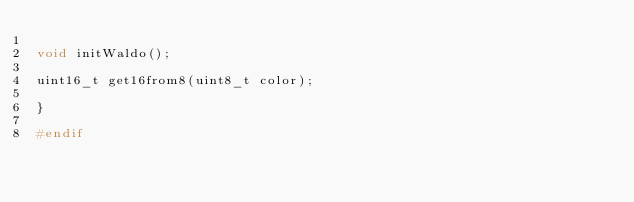Convert code to text. <code><loc_0><loc_0><loc_500><loc_500><_C++_>
void initWaldo();

uint16_t get16from8(uint8_t color);

}

#endif

</code> 